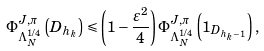<formula> <loc_0><loc_0><loc_500><loc_500>\Phi ^ { J , \pi } _ { \Lambda ^ { 1 / 4 } _ { N } } \left ( D _ { h _ { k } } \right ) \leqslant \left ( 1 - \frac { \varepsilon ^ { 2 } } { 4 } \right ) \Phi ^ { J , \pi } _ { \Lambda ^ { 1 / 4 } _ { N } } \left ( 1 _ { D _ { h _ { k } - 1 } } \right ) ,</formula> 